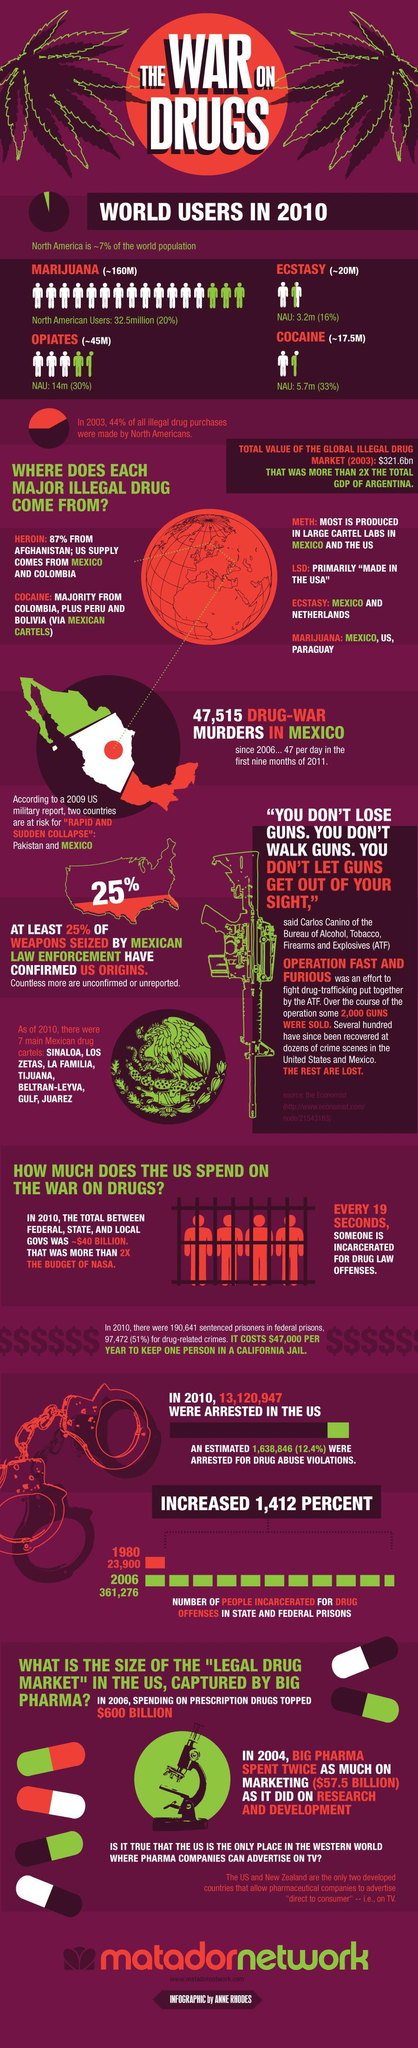what is the number of north American cocaine users?
Answer the question with a short phrase. 5.7m which is the most used illegal drug in the world? 205 